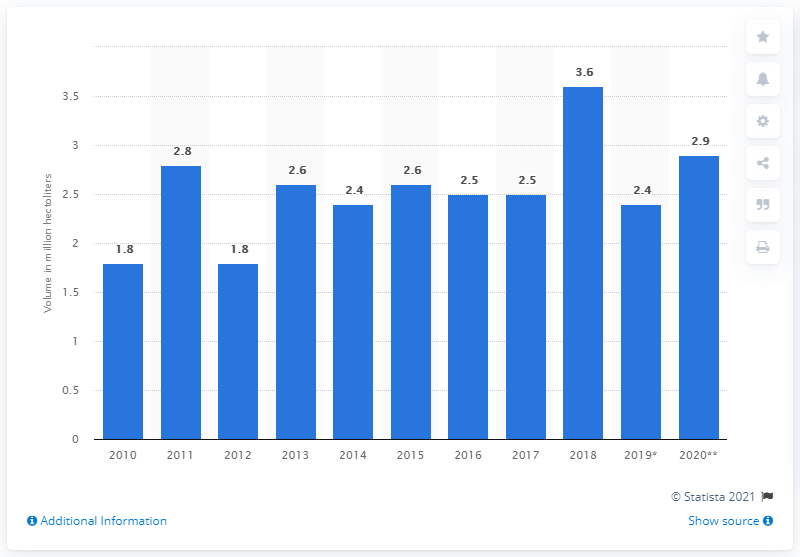Outline some significant characteristics in this image. The volume of wine produced in Hungary in 2020 was 2,900 hectoliters. 